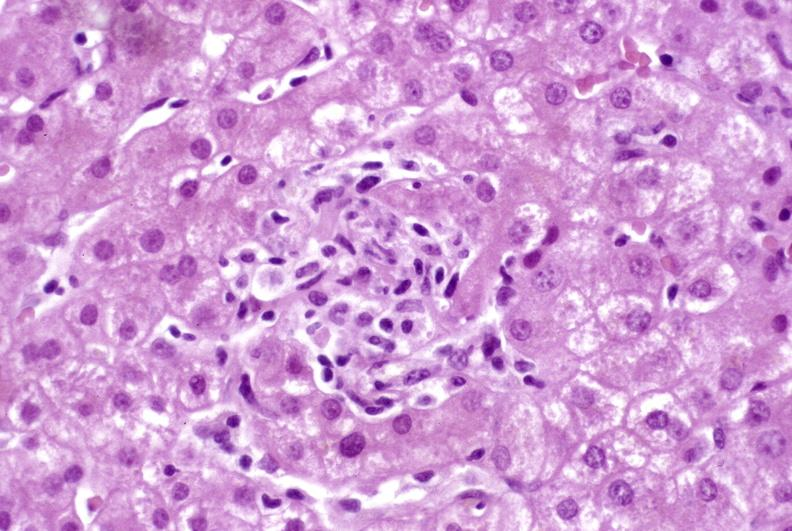s basilar skull fracture present?
Answer the question using a single word or phrase. No 